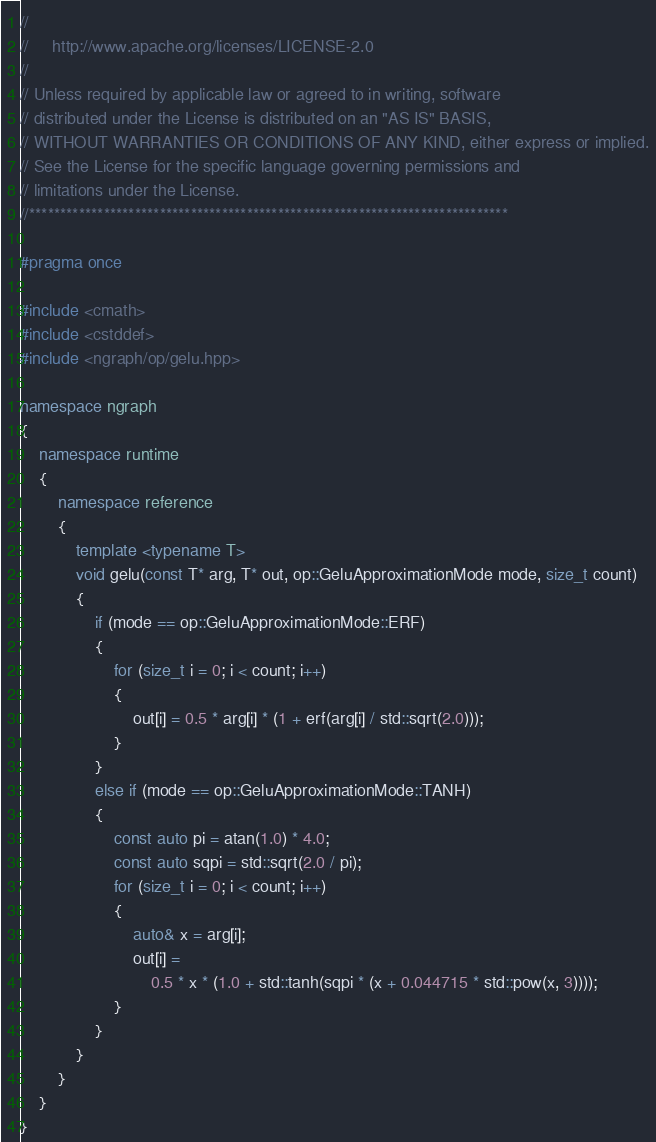<code> <loc_0><loc_0><loc_500><loc_500><_C++_>//
//     http://www.apache.org/licenses/LICENSE-2.0
//
// Unless required by applicable law or agreed to in writing, software
// distributed under the License is distributed on an "AS IS" BASIS,
// WITHOUT WARRANTIES OR CONDITIONS OF ANY KIND, either express or implied.
// See the License for the specific language governing permissions and
// limitations under the License.
//*****************************************************************************

#pragma once

#include <cmath>
#include <cstddef>
#include <ngraph/op/gelu.hpp>

namespace ngraph
{
    namespace runtime
    {
        namespace reference
        {
            template <typename T>
            void gelu(const T* arg, T* out, op::GeluApproximationMode mode, size_t count)
            {
                if (mode == op::GeluApproximationMode::ERF)
                {
                    for (size_t i = 0; i < count; i++)
                    {
                        out[i] = 0.5 * arg[i] * (1 + erf(arg[i] / std::sqrt(2.0)));
                    }
                }
                else if (mode == op::GeluApproximationMode::TANH)
                {
                    const auto pi = atan(1.0) * 4.0;
                    const auto sqpi = std::sqrt(2.0 / pi);
                    for (size_t i = 0; i < count; i++)
                    {
                        auto& x = arg[i];
                        out[i] =
                            0.5 * x * (1.0 + std::tanh(sqpi * (x + 0.044715 * std::pow(x, 3))));
                    }
                }
            }
        }
    }
}
</code> 